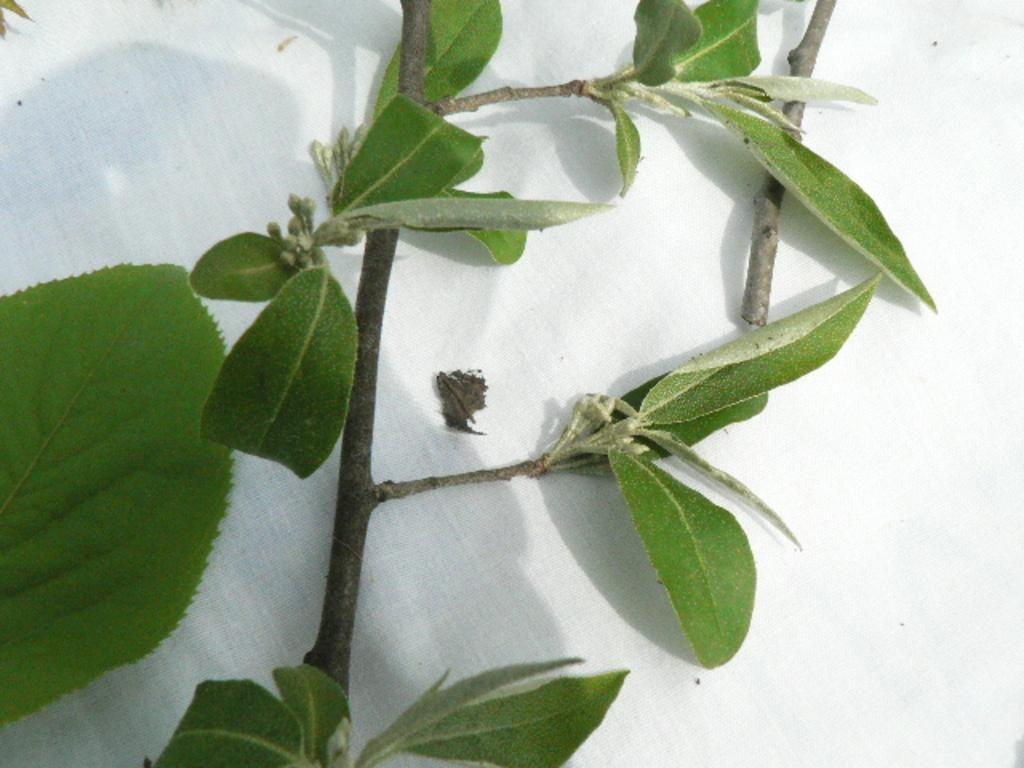What type of living organism is in the image? There is a plant in the image. What are the main parts of the plant visible in the image? The plant has a stem and leaves. What is the plant placed on in the image? The plant is placed on a white cloth. What type of pancake is being used to support the plant in the image? There is no pancake present in the image; the plant is placed on a white cloth. 